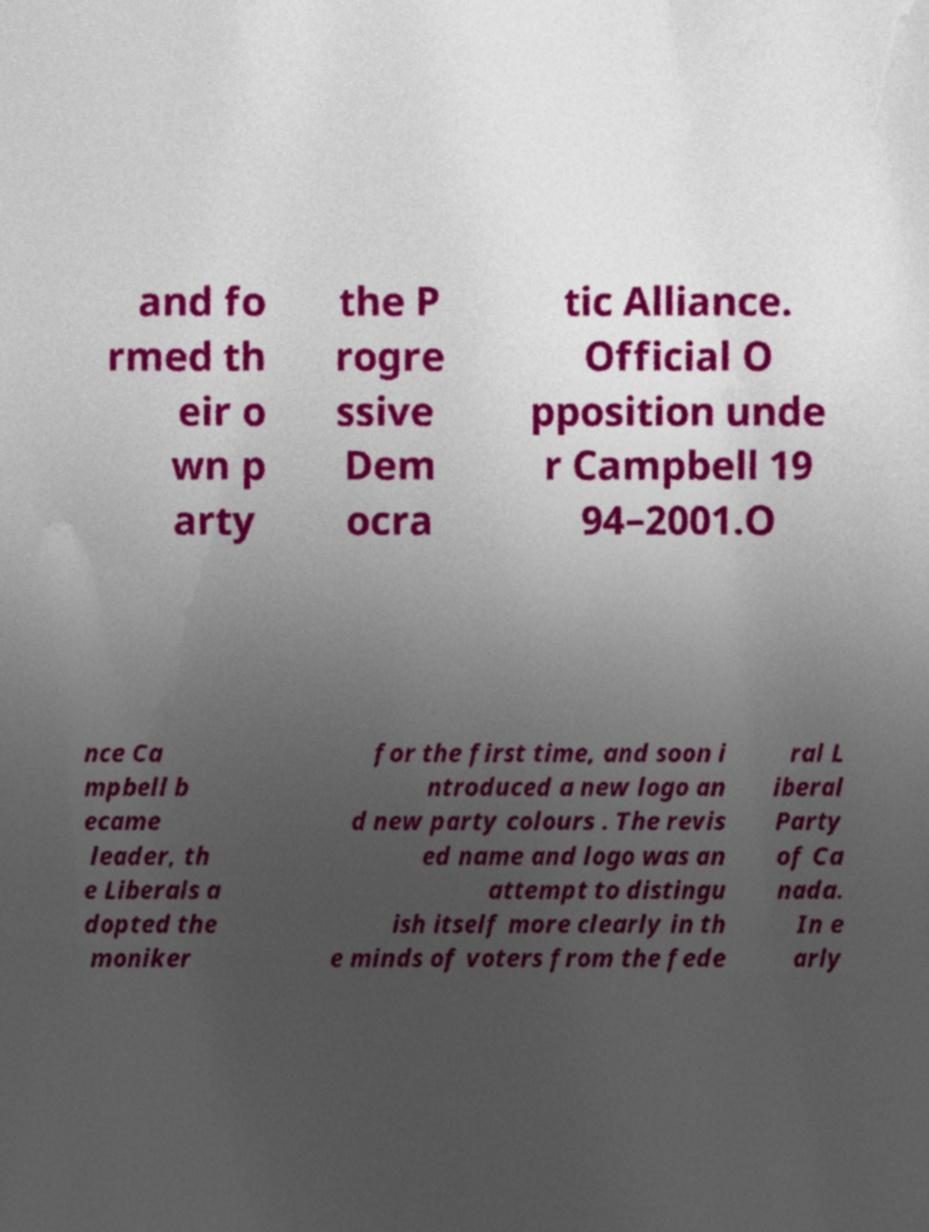I need the written content from this picture converted into text. Can you do that? and fo rmed th eir o wn p arty the P rogre ssive Dem ocra tic Alliance. Official O pposition unde r Campbell 19 94–2001.O nce Ca mpbell b ecame leader, th e Liberals a dopted the moniker for the first time, and soon i ntroduced a new logo an d new party colours . The revis ed name and logo was an attempt to distingu ish itself more clearly in th e minds of voters from the fede ral L iberal Party of Ca nada. In e arly 